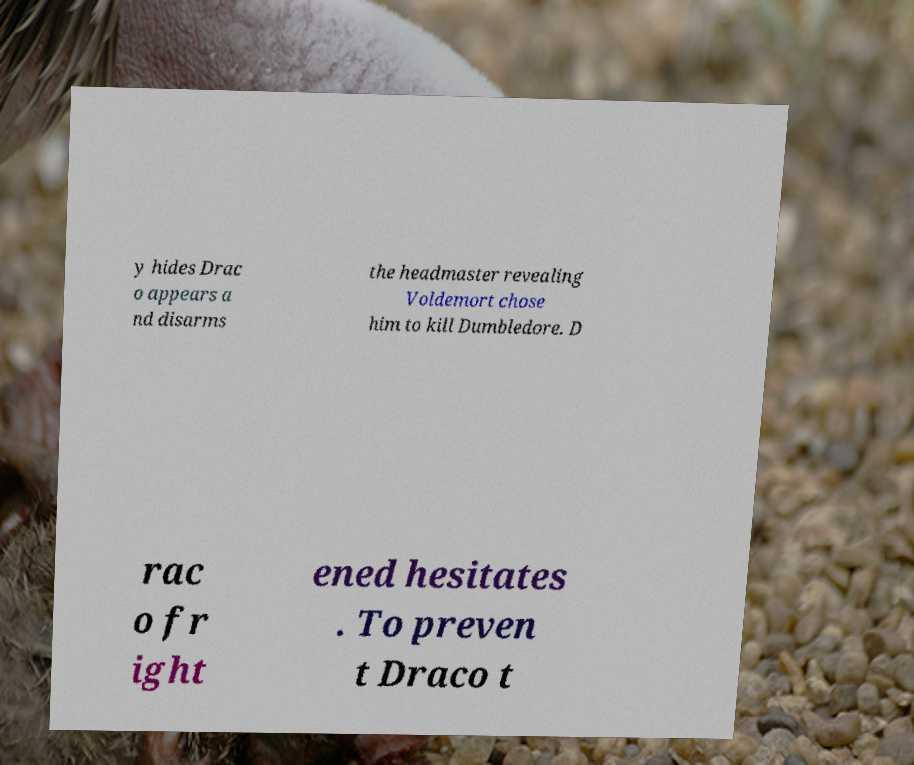I need the written content from this picture converted into text. Can you do that? y hides Drac o appears a nd disarms the headmaster revealing Voldemort chose him to kill Dumbledore. D rac o fr ight ened hesitates . To preven t Draco t 